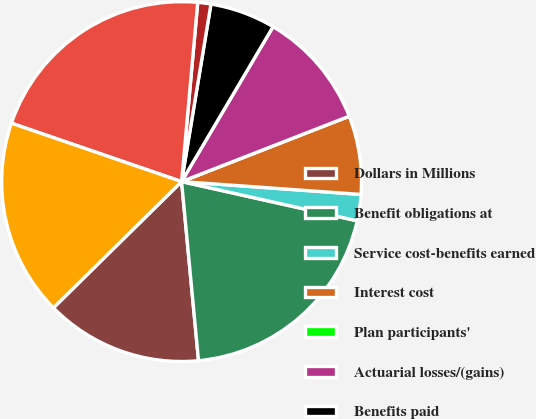Convert chart to OTSL. <chart><loc_0><loc_0><loc_500><loc_500><pie_chart><fcel>Dollars in Millions<fcel>Benefit obligations at<fcel>Service cost-benefits earned<fcel>Interest cost<fcel>Plan participants'<fcel>Actuarial losses/(gains)<fcel>Benefits paid<fcel>Exchange rate losses/(gains)<fcel>Benefit obligations at end of<fcel>Fair value of plan assets at<nl><fcel>14.12%<fcel>20.0%<fcel>2.36%<fcel>7.06%<fcel>0.0%<fcel>10.59%<fcel>5.88%<fcel>1.18%<fcel>21.17%<fcel>17.64%<nl></chart> 